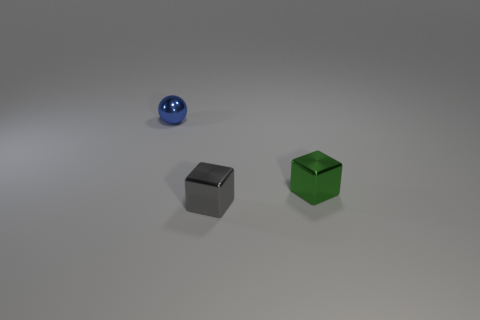Add 3 small green rubber cubes. How many objects exist? 6 Subtract 1 spheres. How many spheres are left? 0 Add 2 gray rubber things. How many gray rubber things exist? 2 Subtract 0 brown cylinders. How many objects are left? 3 Subtract all cubes. How many objects are left? 1 Subtract all blue blocks. Subtract all cyan cylinders. How many blocks are left? 2 Subtract all tiny gray metal cubes. Subtract all tiny brown rubber things. How many objects are left? 2 Add 3 tiny gray things. How many tiny gray things are left? 4 